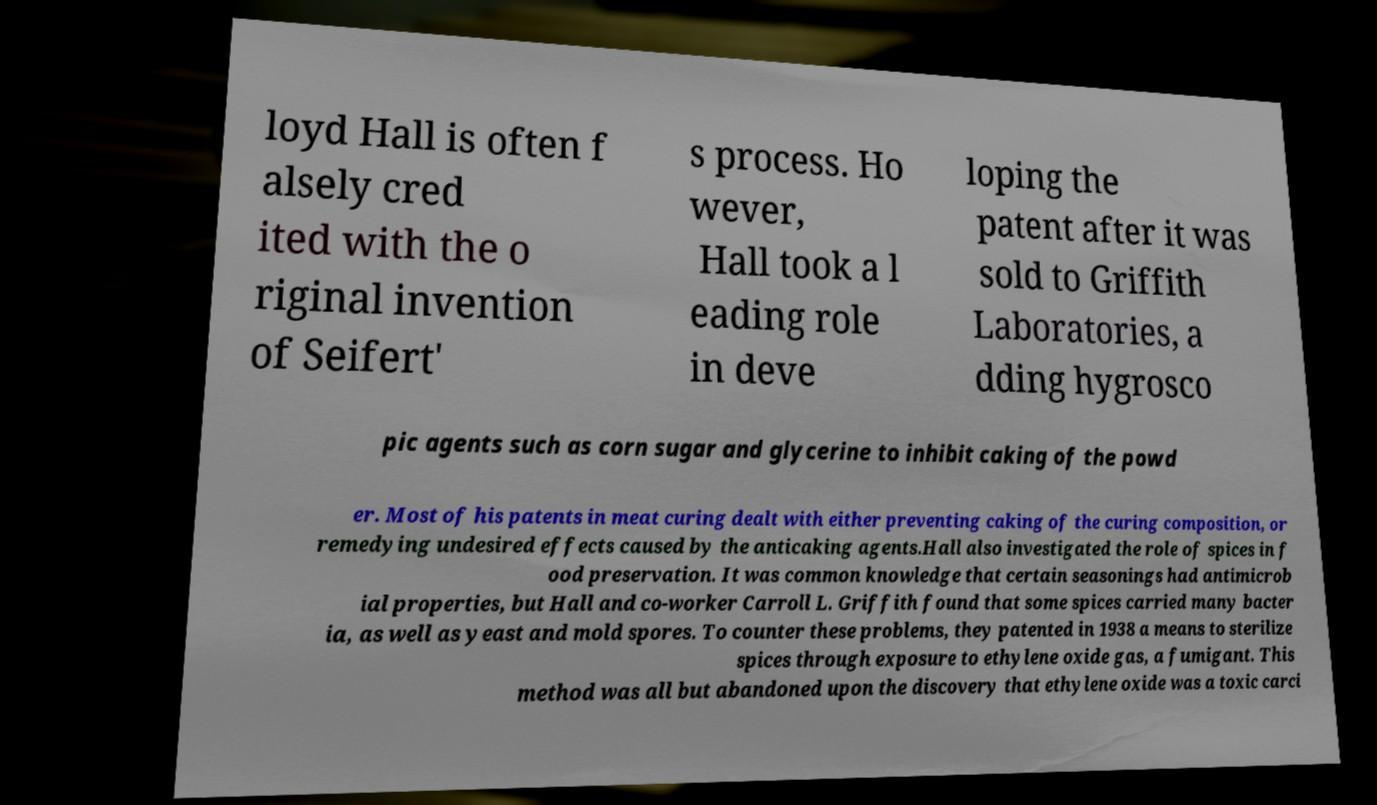Please read and relay the text visible in this image. What does it say? loyd Hall is often f alsely cred ited with the o riginal invention of Seifert' s process. Ho wever, Hall took a l eading role in deve loping the patent after it was sold to Griffith Laboratories, a dding hygrosco pic agents such as corn sugar and glycerine to inhibit caking of the powd er. Most of his patents in meat curing dealt with either preventing caking of the curing composition, or remedying undesired effects caused by the anticaking agents.Hall also investigated the role of spices in f ood preservation. It was common knowledge that certain seasonings had antimicrob ial properties, but Hall and co-worker Carroll L. Griffith found that some spices carried many bacter ia, as well as yeast and mold spores. To counter these problems, they patented in 1938 a means to sterilize spices through exposure to ethylene oxide gas, a fumigant. This method was all but abandoned upon the discovery that ethylene oxide was a toxic carci 